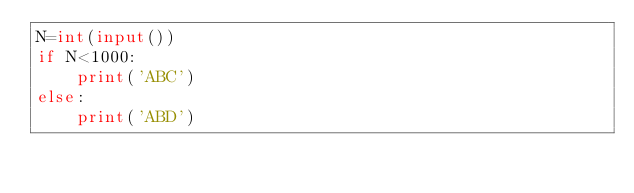Convert code to text. <code><loc_0><loc_0><loc_500><loc_500><_Python_>N=int(input())
if N<1000:
    print('ABC')
else:
    print('ABD')</code> 